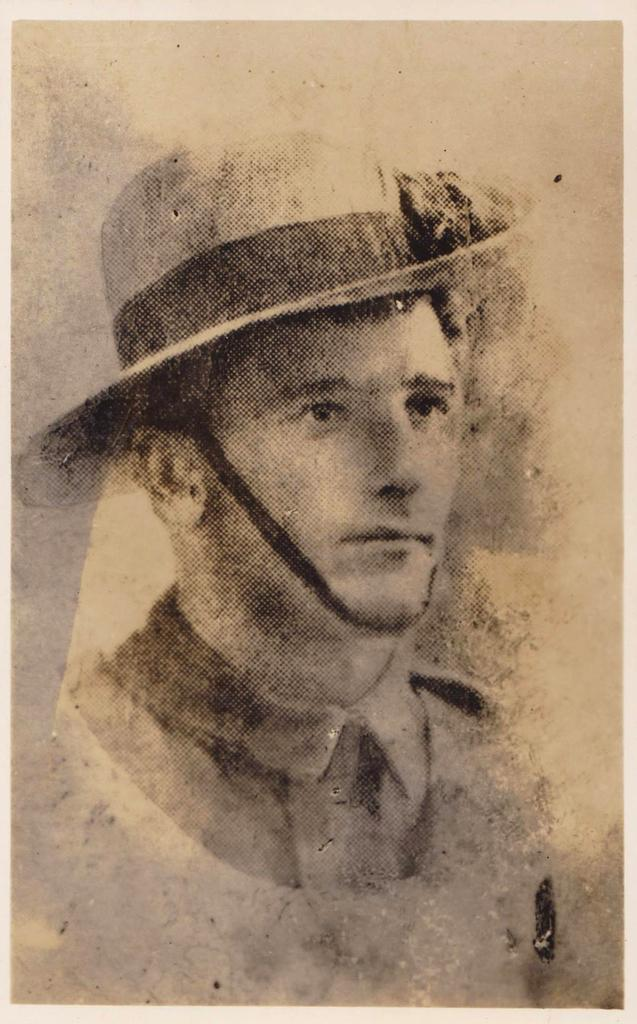What is depicted on the paper in the image? There is an image of a person printed on a paper. What is the person in the image wearing? The person in the image is wearing a hat. Can you tell me how many times the person in the image bites the sidewalk? There is no sidewalk present in the image, nor is there any indication that the person in the image is biting anything. 